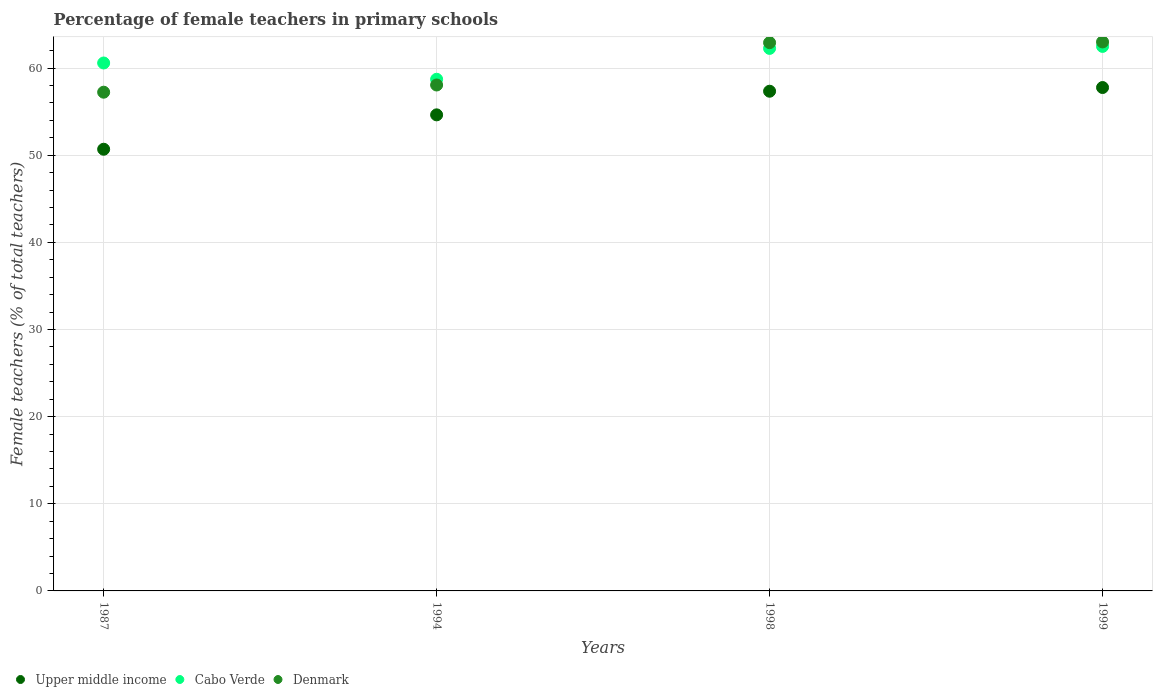How many different coloured dotlines are there?
Your answer should be compact. 3. Is the number of dotlines equal to the number of legend labels?
Ensure brevity in your answer.  Yes. What is the percentage of female teachers in Denmark in 1987?
Your answer should be very brief. 57.23. Across all years, what is the maximum percentage of female teachers in Cabo Verde?
Provide a short and direct response. 62.48. Across all years, what is the minimum percentage of female teachers in Cabo Verde?
Keep it short and to the point. 58.71. What is the total percentage of female teachers in Denmark in the graph?
Make the answer very short. 241.19. What is the difference between the percentage of female teachers in Denmark in 1994 and that in 1999?
Offer a very short reply. -4.94. What is the difference between the percentage of female teachers in Upper middle income in 1998 and the percentage of female teachers in Denmark in 1999?
Your response must be concise. -5.66. What is the average percentage of female teachers in Upper middle income per year?
Your answer should be compact. 55.1. In the year 1987, what is the difference between the percentage of female teachers in Cabo Verde and percentage of female teachers in Upper middle income?
Offer a terse response. 9.9. In how many years, is the percentage of female teachers in Upper middle income greater than 16 %?
Ensure brevity in your answer.  4. What is the ratio of the percentage of female teachers in Upper middle income in 1987 to that in 1994?
Ensure brevity in your answer.  0.93. Is the percentage of female teachers in Cabo Verde in 1998 less than that in 1999?
Ensure brevity in your answer.  Yes. What is the difference between the highest and the second highest percentage of female teachers in Upper middle income?
Your response must be concise. 0.42. What is the difference between the highest and the lowest percentage of female teachers in Upper middle income?
Your answer should be very brief. 7.08. In how many years, is the percentage of female teachers in Upper middle income greater than the average percentage of female teachers in Upper middle income taken over all years?
Your response must be concise. 2. Is the sum of the percentage of female teachers in Denmark in 1998 and 1999 greater than the maximum percentage of female teachers in Cabo Verde across all years?
Offer a very short reply. Yes. Is the percentage of female teachers in Cabo Verde strictly less than the percentage of female teachers in Upper middle income over the years?
Offer a very short reply. No. How many dotlines are there?
Provide a succinct answer. 3. How many years are there in the graph?
Keep it short and to the point. 4. Are the values on the major ticks of Y-axis written in scientific E-notation?
Ensure brevity in your answer.  No. Does the graph contain any zero values?
Ensure brevity in your answer.  No. Where does the legend appear in the graph?
Provide a succinct answer. Bottom left. What is the title of the graph?
Keep it short and to the point. Percentage of female teachers in primary schools. Does "Oman" appear as one of the legend labels in the graph?
Offer a very short reply. No. What is the label or title of the Y-axis?
Keep it short and to the point. Female teachers (% of total teachers). What is the Female teachers (% of total teachers) of Upper middle income in 1987?
Keep it short and to the point. 50.68. What is the Female teachers (% of total teachers) of Cabo Verde in 1987?
Provide a succinct answer. 60.58. What is the Female teachers (% of total teachers) of Denmark in 1987?
Provide a succinct answer. 57.23. What is the Female teachers (% of total teachers) in Upper middle income in 1994?
Your answer should be compact. 54.63. What is the Female teachers (% of total teachers) in Cabo Verde in 1994?
Keep it short and to the point. 58.71. What is the Female teachers (% of total teachers) in Denmark in 1994?
Ensure brevity in your answer.  58.05. What is the Female teachers (% of total teachers) in Upper middle income in 1998?
Keep it short and to the point. 57.34. What is the Female teachers (% of total teachers) of Cabo Verde in 1998?
Your answer should be very brief. 62.26. What is the Female teachers (% of total teachers) of Denmark in 1998?
Your answer should be very brief. 62.91. What is the Female teachers (% of total teachers) in Upper middle income in 1999?
Provide a short and direct response. 57.76. What is the Female teachers (% of total teachers) in Cabo Verde in 1999?
Your answer should be compact. 62.48. What is the Female teachers (% of total teachers) in Denmark in 1999?
Your response must be concise. 63. Across all years, what is the maximum Female teachers (% of total teachers) of Upper middle income?
Provide a succinct answer. 57.76. Across all years, what is the maximum Female teachers (% of total teachers) in Cabo Verde?
Provide a short and direct response. 62.48. Across all years, what is the maximum Female teachers (% of total teachers) of Denmark?
Make the answer very short. 63. Across all years, what is the minimum Female teachers (% of total teachers) of Upper middle income?
Your answer should be compact. 50.68. Across all years, what is the minimum Female teachers (% of total teachers) in Cabo Verde?
Keep it short and to the point. 58.71. Across all years, what is the minimum Female teachers (% of total teachers) of Denmark?
Offer a terse response. 57.23. What is the total Female teachers (% of total teachers) of Upper middle income in the graph?
Offer a very short reply. 220.42. What is the total Female teachers (% of total teachers) in Cabo Verde in the graph?
Your answer should be compact. 244.03. What is the total Female teachers (% of total teachers) of Denmark in the graph?
Make the answer very short. 241.19. What is the difference between the Female teachers (% of total teachers) in Upper middle income in 1987 and that in 1994?
Give a very brief answer. -3.95. What is the difference between the Female teachers (% of total teachers) in Cabo Verde in 1987 and that in 1994?
Offer a terse response. 1.87. What is the difference between the Female teachers (% of total teachers) in Denmark in 1987 and that in 1994?
Offer a very short reply. -0.83. What is the difference between the Female teachers (% of total teachers) of Upper middle income in 1987 and that in 1998?
Give a very brief answer. -6.66. What is the difference between the Female teachers (% of total teachers) in Cabo Verde in 1987 and that in 1998?
Your answer should be compact. -1.67. What is the difference between the Female teachers (% of total teachers) in Denmark in 1987 and that in 1998?
Offer a terse response. -5.68. What is the difference between the Female teachers (% of total teachers) in Upper middle income in 1987 and that in 1999?
Offer a very short reply. -7.08. What is the difference between the Female teachers (% of total teachers) in Cabo Verde in 1987 and that in 1999?
Ensure brevity in your answer.  -1.9. What is the difference between the Female teachers (% of total teachers) in Denmark in 1987 and that in 1999?
Your answer should be compact. -5.77. What is the difference between the Female teachers (% of total teachers) of Upper middle income in 1994 and that in 1998?
Keep it short and to the point. -2.71. What is the difference between the Female teachers (% of total teachers) of Cabo Verde in 1994 and that in 1998?
Your response must be concise. -3.54. What is the difference between the Female teachers (% of total teachers) in Denmark in 1994 and that in 1998?
Give a very brief answer. -4.86. What is the difference between the Female teachers (% of total teachers) in Upper middle income in 1994 and that in 1999?
Offer a terse response. -3.14. What is the difference between the Female teachers (% of total teachers) in Cabo Verde in 1994 and that in 1999?
Make the answer very short. -3.77. What is the difference between the Female teachers (% of total teachers) in Denmark in 1994 and that in 1999?
Your answer should be compact. -4.94. What is the difference between the Female teachers (% of total teachers) of Upper middle income in 1998 and that in 1999?
Provide a short and direct response. -0.42. What is the difference between the Female teachers (% of total teachers) of Cabo Verde in 1998 and that in 1999?
Ensure brevity in your answer.  -0.23. What is the difference between the Female teachers (% of total teachers) in Denmark in 1998 and that in 1999?
Ensure brevity in your answer.  -0.08. What is the difference between the Female teachers (% of total teachers) in Upper middle income in 1987 and the Female teachers (% of total teachers) in Cabo Verde in 1994?
Offer a very short reply. -8.03. What is the difference between the Female teachers (% of total teachers) of Upper middle income in 1987 and the Female teachers (% of total teachers) of Denmark in 1994?
Your answer should be very brief. -7.37. What is the difference between the Female teachers (% of total teachers) in Cabo Verde in 1987 and the Female teachers (% of total teachers) in Denmark in 1994?
Provide a short and direct response. 2.53. What is the difference between the Female teachers (% of total teachers) in Upper middle income in 1987 and the Female teachers (% of total teachers) in Cabo Verde in 1998?
Provide a succinct answer. -11.57. What is the difference between the Female teachers (% of total teachers) of Upper middle income in 1987 and the Female teachers (% of total teachers) of Denmark in 1998?
Your response must be concise. -12.23. What is the difference between the Female teachers (% of total teachers) in Cabo Verde in 1987 and the Female teachers (% of total teachers) in Denmark in 1998?
Provide a succinct answer. -2.33. What is the difference between the Female teachers (% of total teachers) of Upper middle income in 1987 and the Female teachers (% of total teachers) of Cabo Verde in 1999?
Offer a terse response. -11.8. What is the difference between the Female teachers (% of total teachers) in Upper middle income in 1987 and the Female teachers (% of total teachers) in Denmark in 1999?
Your answer should be compact. -12.31. What is the difference between the Female teachers (% of total teachers) of Cabo Verde in 1987 and the Female teachers (% of total teachers) of Denmark in 1999?
Offer a very short reply. -2.42. What is the difference between the Female teachers (% of total teachers) in Upper middle income in 1994 and the Female teachers (% of total teachers) in Cabo Verde in 1998?
Your answer should be compact. -7.63. What is the difference between the Female teachers (% of total teachers) of Upper middle income in 1994 and the Female teachers (% of total teachers) of Denmark in 1998?
Offer a very short reply. -8.28. What is the difference between the Female teachers (% of total teachers) in Cabo Verde in 1994 and the Female teachers (% of total teachers) in Denmark in 1998?
Provide a short and direct response. -4.2. What is the difference between the Female teachers (% of total teachers) in Upper middle income in 1994 and the Female teachers (% of total teachers) in Cabo Verde in 1999?
Ensure brevity in your answer.  -7.86. What is the difference between the Female teachers (% of total teachers) in Upper middle income in 1994 and the Female teachers (% of total teachers) in Denmark in 1999?
Offer a very short reply. -8.37. What is the difference between the Female teachers (% of total teachers) of Cabo Verde in 1994 and the Female teachers (% of total teachers) of Denmark in 1999?
Make the answer very short. -4.28. What is the difference between the Female teachers (% of total teachers) of Upper middle income in 1998 and the Female teachers (% of total teachers) of Cabo Verde in 1999?
Make the answer very short. -5.14. What is the difference between the Female teachers (% of total teachers) of Upper middle income in 1998 and the Female teachers (% of total teachers) of Denmark in 1999?
Make the answer very short. -5.66. What is the difference between the Female teachers (% of total teachers) of Cabo Verde in 1998 and the Female teachers (% of total teachers) of Denmark in 1999?
Provide a short and direct response. -0.74. What is the average Female teachers (% of total teachers) in Upper middle income per year?
Make the answer very short. 55.1. What is the average Female teachers (% of total teachers) in Cabo Verde per year?
Make the answer very short. 61.01. What is the average Female teachers (% of total teachers) in Denmark per year?
Your answer should be very brief. 60.3. In the year 1987, what is the difference between the Female teachers (% of total teachers) of Upper middle income and Female teachers (% of total teachers) of Cabo Verde?
Make the answer very short. -9.9. In the year 1987, what is the difference between the Female teachers (% of total teachers) of Upper middle income and Female teachers (% of total teachers) of Denmark?
Give a very brief answer. -6.55. In the year 1987, what is the difference between the Female teachers (% of total teachers) of Cabo Verde and Female teachers (% of total teachers) of Denmark?
Ensure brevity in your answer.  3.35. In the year 1994, what is the difference between the Female teachers (% of total teachers) of Upper middle income and Female teachers (% of total teachers) of Cabo Verde?
Offer a very short reply. -4.08. In the year 1994, what is the difference between the Female teachers (% of total teachers) in Upper middle income and Female teachers (% of total teachers) in Denmark?
Offer a terse response. -3.43. In the year 1994, what is the difference between the Female teachers (% of total teachers) of Cabo Verde and Female teachers (% of total teachers) of Denmark?
Your response must be concise. 0.66. In the year 1998, what is the difference between the Female teachers (% of total teachers) of Upper middle income and Female teachers (% of total teachers) of Cabo Verde?
Offer a terse response. -4.91. In the year 1998, what is the difference between the Female teachers (% of total teachers) in Upper middle income and Female teachers (% of total teachers) in Denmark?
Keep it short and to the point. -5.57. In the year 1998, what is the difference between the Female teachers (% of total teachers) in Cabo Verde and Female teachers (% of total teachers) in Denmark?
Your answer should be compact. -0.66. In the year 1999, what is the difference between the Female teachers (% of total teachers) of Upper middle income and Female teachers (% of total teachers) of Cabo Verde?
Offer a terse response. -4.72. In the year 1999, what is the difference between the Female teachers (% of total teachers) of Upper middle income and Female teachers (% of total teachers) of Denmark?
Provide a short and direct response. -5.23. In the year 1999, what is the difference between the Female teachers (% of total teachers) of Cabo Verde and Female teachers (% of total teachers) of Denmark?
Provide a short and direct response. -0.51. What is the ratio of the Female teachers (% of total teachers) in Upper middle income in 1987 to that in 1994?
Your answer should be very brief. 0.93. What is the ratio of the Female teachers (% of total teachers) of Cabo Verde in 1987 to that in 1994?
Make the answer very short. 1.03. What is the ratio of the Female teachers (% of total teachers) in Denmark in 1987 to that in 1994?
Offer a very short reply. 0.99. What is the ratio of the Female teachers (% of total teachers) in Upper middle income in 1987 to that in 1998?
Make the answer very short. 0.88. What is the ratio of the Female teachers (% of total teachers) of Cabo Verde in 1987 to that in 1998?
Your answer should be compact. 0.97. What is the ratio of the Female teachers (% of total teachers) of Denmark in 1987 to that in 1998?
Your response must be concise. 0.91. What is the ratio of the Female teachers (% of total teachers) of Upper middle income in 1987 to that in 1999?
Offer a very short reply. 0.88. What is the ratio of the Female teachers (% of total teachers) in Cabo Verde in 1987 to that in 1999?
Your answer should be compact. 0.97. What is the ratio of the Female teachers (% of total teachers) in Denmark in 1987 to that in 1999?
Keep it short and to the point. 0.91. What is the ratio of the Female teachers (% of total teachers) in Upper middle income in 1994 to that in 1998?
Provide a succinct answer. 0.95. What is the ratio of the Female teachers (% of total teachers) of Cabo Verde in 1994 to that in 1998?
Offer a terse response. 0.94. What is the ratio of the Female teachers (% of total teachers) in Denmark in 1994 to that in 1998?
Your answer should be compact. 0.92. What is the ratio of the Female teachers (% of total teachers) of Upper middle income in 1994 to that in 1999?
Provide a short and direct response. 0.95. What is the ratio of the Female teachers (% of total teachers) of Cabo Verde in 1994 to that in 1999?
Your answer should be compact. 0.94. What is the ratio of the Female teachers (% of total teachers) in Denmark in 1994 to that in 1999?
Keep it short and to the point. 0.92. What is the ratio of the Female teachers (% of total teachers) of Cabo Verde in 1998 to that in 1999?
Provide a succinct answer. 1. What is the difference between the highest and the second highest Female teachers (% of total teachers) in Upper middle income?
Offer a very short reply. 0.42. What is the difference between the highest and the second highest Female teachers (% of total teachers) in Cabo Verde?
Ensure brevity in your answer.  0.23. What is the difference between the highest and the second highest Female teachers (% of total teachers) of Denmark?
Your response must be concise. 0.08. What is the difference between the highest and the lowest Female teachers (% of total teachers) of Upper middle income?
Your response must be concise. 7.08. What is the difference between the highest and the lowest Female teachers (% of total teachers) of Cabo Verde?
Make the answer very short. 3.77. What is the difference between the highest and the lowest Female teachers (% of total teachers) of Denmark?
Your answer should be compact. 5.77. 